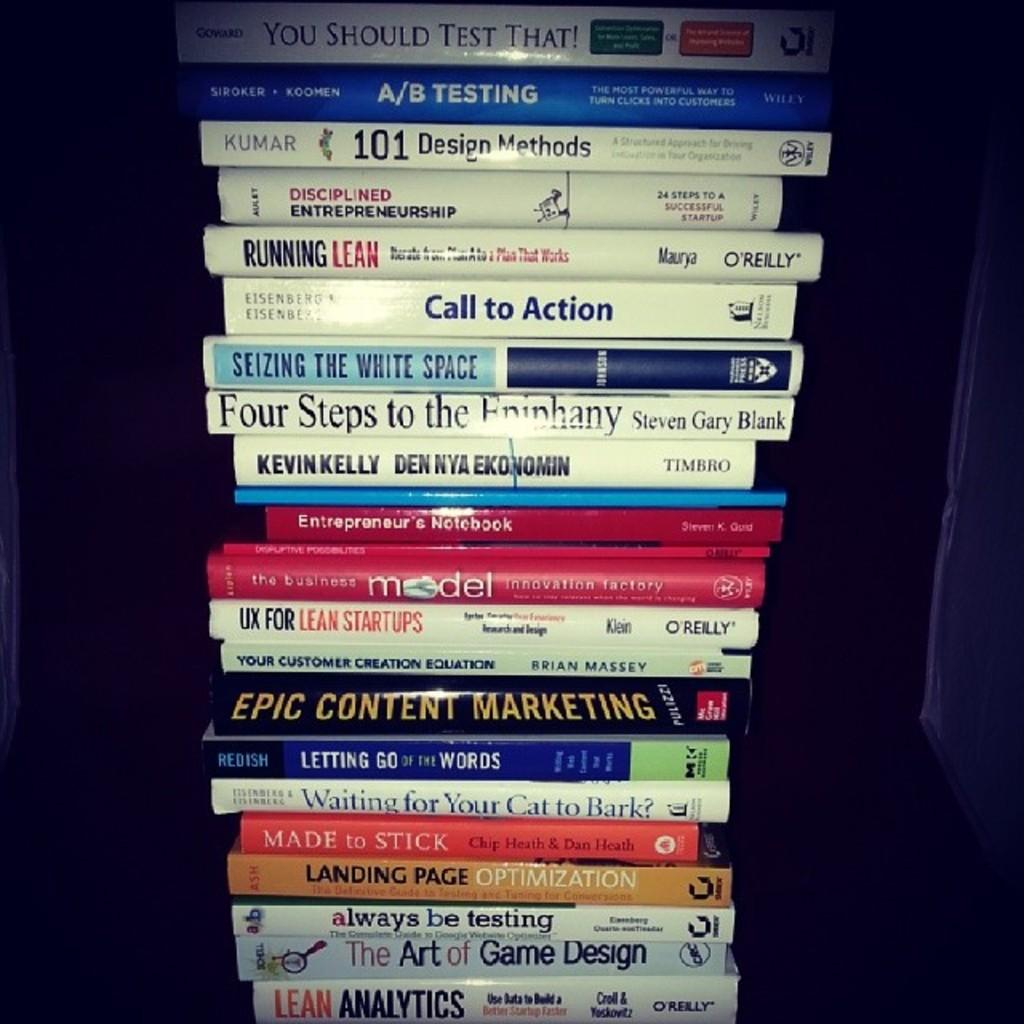Provide a one-sentence caption for the provided image. You should test that book on top and Lean Analytics book on the bottom. 